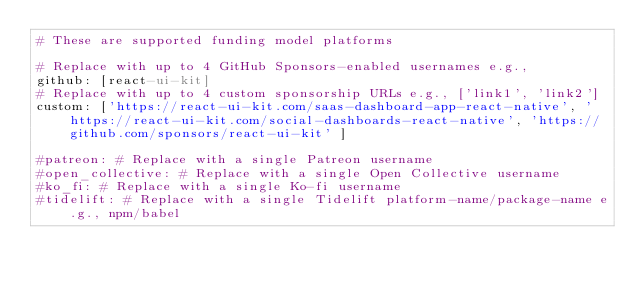Convert code to text. <code><loc_0><loc_0><loc_500><loc_500><_YAML_># These are supported funding model platforms

# Replace with up to 4 GitHub Sponsors-enabled usernames e.g.,
github: [react-ui-kit]
# Replace with up to 4 custom sponsorship URLs e.g., ['link1', 'link2']
custom: ['https://react-ui-kit.com/saas-dashboard-app-react-native', 'https://react-ui-kit.com/social-dashboards-react-native', 'https://github.com/sponsors/react-ui-kit' ]

#patreon: # Replace with a single Patreon username
#open_collective: # Replace with a single Open Collective username
#ko_fi: # Replace with a single Ko-fi username
#tidelift: # Replace with a single Tidelift platform-name/package-name e.g., npm/babel</code> 